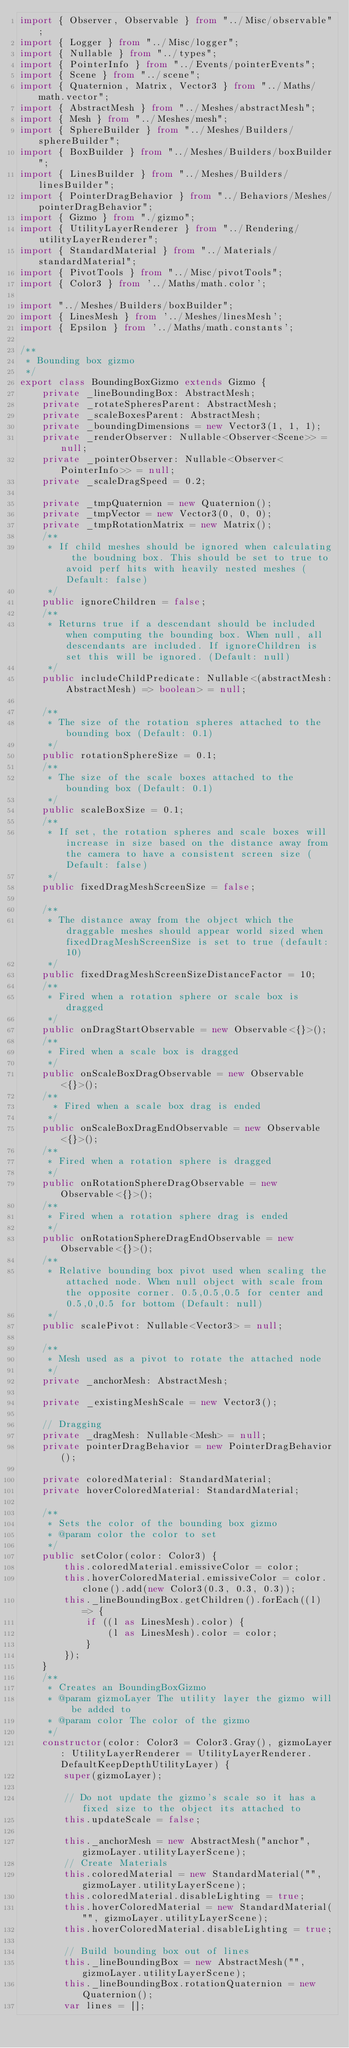Convert code to text. <code><loc_0><loc_0><loc_500><loc_500><_TypeScript_>import { Observer, Observable } from "../Misc/observable";
import { Logger } from "../Misc/logger";
import { Nullable } from "../types";
import { PointerInfo } from "../Events/pointerEvents";
import { Scene } from "../scene";
import { Quaternion, Matrix, Vector3 } from "../Maths/math.vector";
import { AbstractMesh } from "../Meshes/abstractMesh";
import { Mesh } from "../Meshes/mesh";
import { SphereBuilder } from "../Meshes/Builders/sphereBuilder";
import { BoxBuilder } from "../Meshes/Builders/boxBuilder";
import { LinesBuilder } from "../Meshes/Builders/linesBuilder";
import { PointerDragBehavior } from "../Behaviors/Meshes/pointerDragBehavior";
import { Gizmo } from "./gizmo";
import { UtilityLayerRenderer } from "../Rendering/utilityLayerRenderer";
import { StandardMaterial } from "../Materials/standardMaterial";
import { PivotTools } from "../Misc/pivotTools";
import { Color3 } from '../Maths/math.color';

import "../Meshes/Builders/boxBuilder";
import { LinesMesh } from '../Meshes/linesMesh';
import { Epsilon } from '../Maths/math.constants';

/**
 * Bounding box gizmo
 */
export class BoundingBoxGizmo extends Gizmo {
    private _lineBoundingBox: AbstractMesh;
    private _rotateSpheresParent: AbstractMesh;
    private _scaleBoxesParent: AbstractMesh;
    private _boundingDimensions = new Vector3(1, 1, 1);
    private _renderObserver: Nullable<Observer<Scene>> = null;
    private _pointerObserver: Nullable<Observer<PointerInfo>> = null;
    private _scaleDragSpeed = 0.2;

    private _tmpQuaternion = new Quaternion();
    private _tmpVector = new Vector3(0, 0, 0);
    private _tmpRotationMatrix = new Matrix();
    /**
     * If child meshes should be ignored when calculating the boudning box. This should be set to true to avoid perf hits with heavily nested meshes (Default: false)
     */
    public ignoreChildren = false;
    /**
     * Returns true if a descendant should be included when computing the bounding box. When null, all descendants are included. If ignoreChildren is set this will be ignored. (Default: null)
     */
    public includeChildPredicate: Nullable<(abstractMesh: AbstractMesh) => boolean> = null;

    /**
     * The size of the rotation spheres attached to the bounding box (Default: 0.1)
     */
    public rotationSphereSize = 0.1;
    /**
     * The size of the scale boxes attached to the bounding box (Default: 0.1)
     */
    public scaleBoxSize = 0.1;
    /**
     * If set, the rotation spheres and scale boxes will increase in size based on the distance away from the camera to have a consistent screen size (Default: false)
     */
    public fixedDragMeshScreenSize = false;

    /**
     * The distance away from the object which the draggable meshes should appear world sized when fixedDragMeshScreenSize is set to true (default: 10)
     */
    public fixedDragMeshScreenSizeDistanceFactor = 10;
    /**
     * Fired when a rotation sphere or scale box is dragged
     */
    public onDragStartObservable = new Observable<{}>();
    /**
     * Fired when a scale box is dragged
     */
    public onScaleBoxDragObservable = new Observable<{}>();
    /**
      * Fired when a scale box drag is ended
     */
    public onScaleBoxDragEndObservable = new Observable<{}>();
    /**
     * Fired when a rotation sphere is dragged
     */
    public onRotationSphereDragObservable = new Observable<{}>();
    /**
     * Fired when a rotation sphere drag is ended
     */
    public onRotationSphereDragEndObservable = new Observable<{}>();
    /**
     * Relative bounding box pivot used when scaling the attached node. When null object with scale from the opposite corner. 0.5,0.5,0.5 for center and 0.5,0,0.5 for bottom (Default: null)
     */
    public scalePivot: Nullable<Vector3> = null;

    /**
     * Mesh used as a pivot to rotate the attached node
     */
    private _anchorMesh: AbstractMesh;

    private _existingMeshScale = new Vector3();

    // Dragging
    private _dragMesh: Nullable<Mesh> = null;
    private pointerDragBehavior = new PointerDragBehavior();

    private coloredMaterial: StandardMaterial;
    private hoverColoredMaterial: StandardMaterial;

    /**
     * Sets the color of the bounding box gizmo
     * @param color the color to set
     */
    public setColor(color: Color3) {
        this.coloredMaterial.emissiveColor = color;
        this.hoverColoredMaterial.emissiveColor = color.clone().add(new Color3(0.3, 0.3, 0.3));
        this._lineBoundingBox.getChildren().forEach((l) => {
            if ((l as LinesMesh).color) {
                (l as LinesMesh).color = color;
            }
        });
    }
    /**
     * Creates an BoundingBoxGizmo
     * @param gizmoLayer The utility layer the gizmo will be added to
     * @param color The color of the gizmo
     */
    constructor(color: Color3 = Color3.Gray(), gizmoLayer: UtilityLayerRenderer = UtilityLayerRenderer.DefaultKeepDepthUtilityLayer) {
        super(gizmoLayer);

        // Do not update the gizmo's scale so it has a fixed size to the object its attached to
        this.updateScale = false;

        this._anchorMesh = new AbstractMesh("anchor", gizmoLayer.utilityLayerScene);
        // Create Materials
        this.coloredMaterial = new StandardMaterial("", gizmoLayer.utilityLayerScene);
        this.coloredMaterial.disableLighting = true;
        this.hoverColoredMaterial = new StandardMaterial("", gizmoLayer.utilityLayerScene);
        this.hoverColoredMaterial.disableLighting = true;

        // Build bounding box out of lines
        this._lineBoundingBox = new AbstractMesh("", gizmoLayer.utilityLayerScene);
        this._lineBoundingBox.rotationQuaternion = new Quaternion();
        var lines = [];</code> 